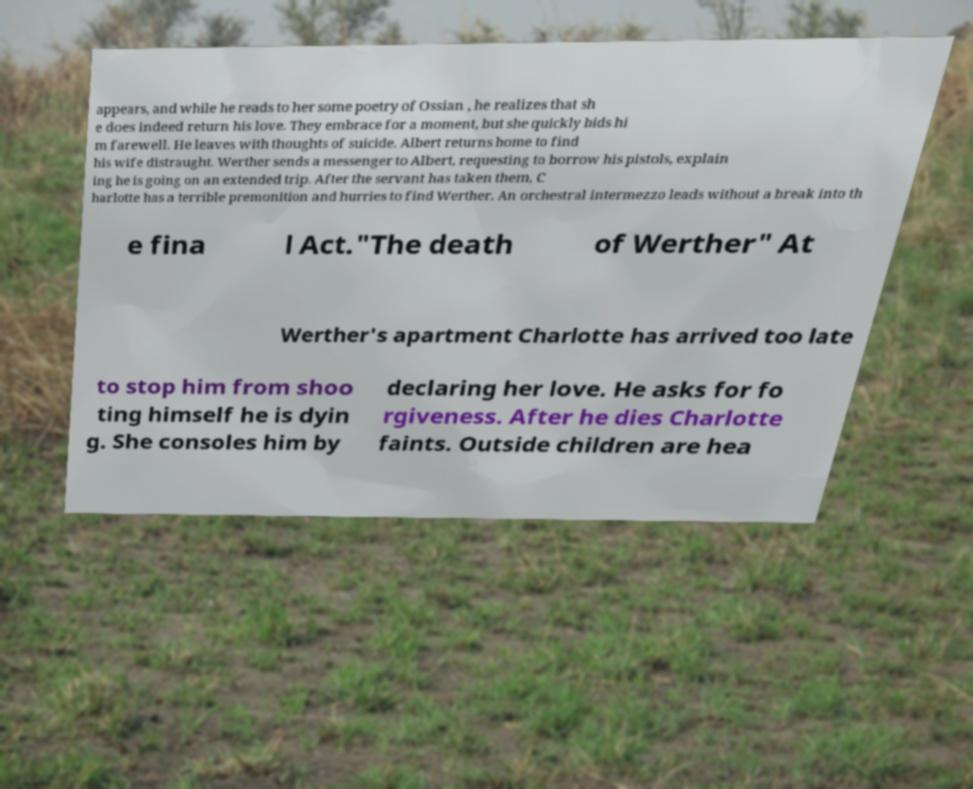What messages or text are displayed in this image? I need them in a readable, typed format. appears, and while he reads to her some poetry of Ossian , he realizes that sh e does indeed return his love. They embrace for a moment, but she quickly bids hi m farewell. He leaves with thoughts of suicide. Albert returns home to find his wife distraught. Werther sends a messenger to Albert, requesting to borrow his pistols, explain ing he is going on an extended trip. After the servant has taken them, C harlotte has a terrible premonition and hurries to find Werther. An orchestral intermezzo leads without a break into th e fina l Act."The death of Werther" At Werther's apartment Charlotte has arrived too late to stop him from shoo ting himself he is dyin g. She consoles him by declaring her love. He asks for fo rgiveness. After he dies Charlotte faints. Outside children are hea 